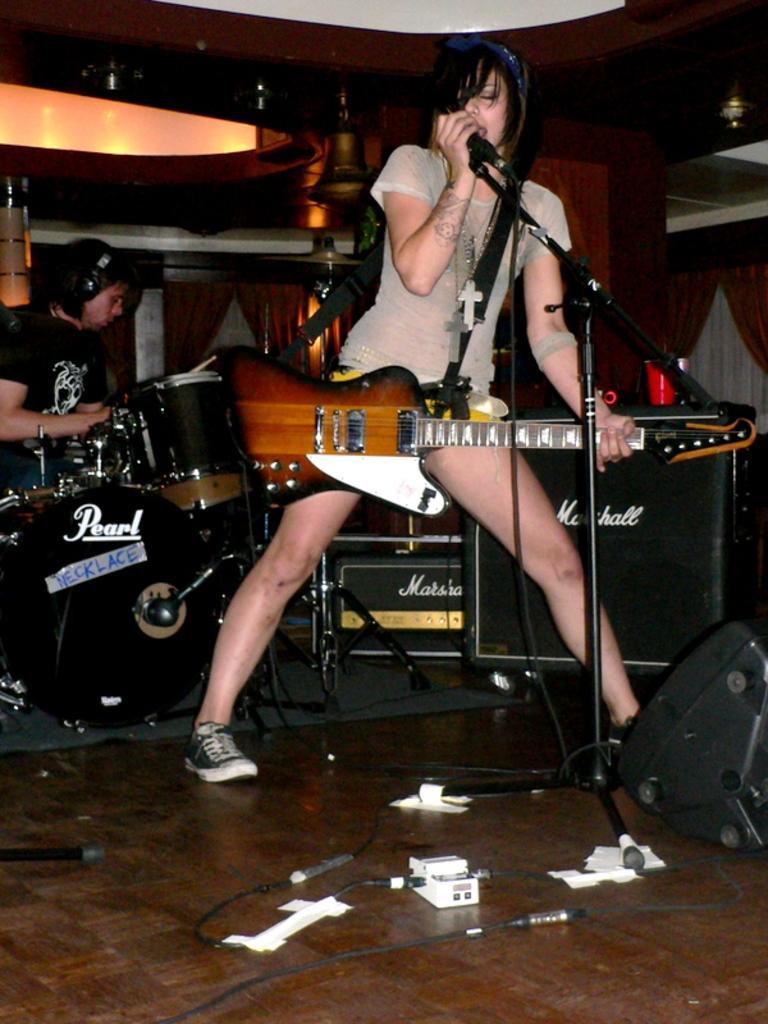Please provide a concise description of this image. In this image there are two persons, one woman and one man. Woman is singing on a mike and she was holding a guitar and she is wearing a white colored dress and black shoes. A man is in the left side and he was sitting and playing drums. 